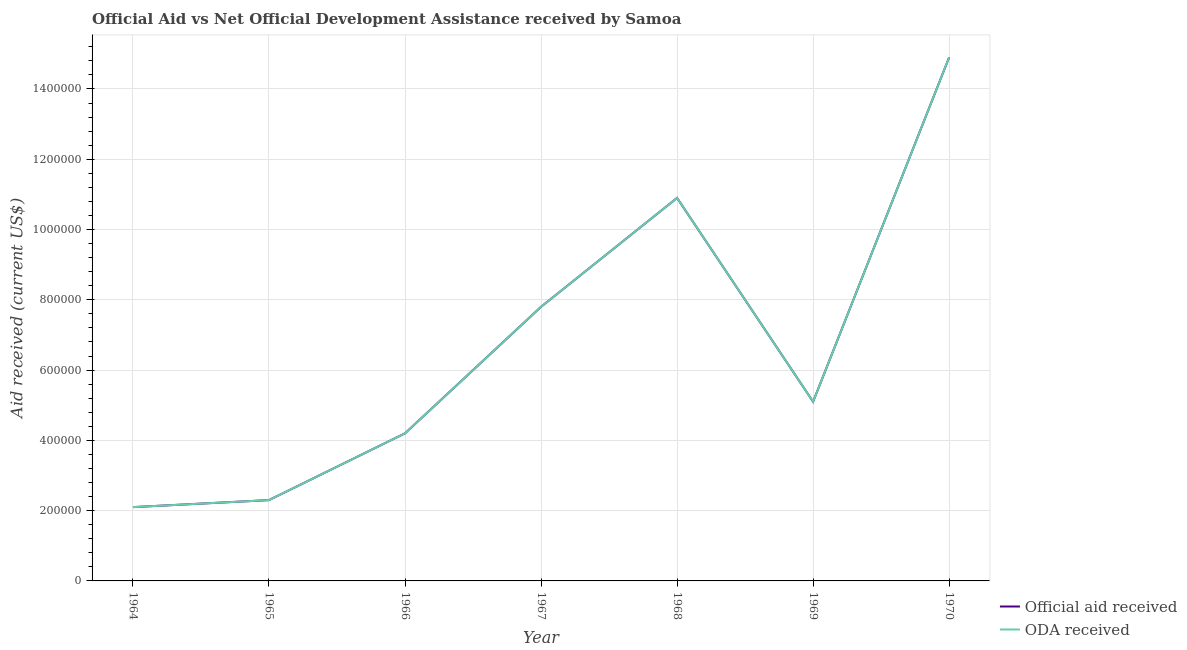Is the number of lines equal to the number of legend labels?
Your response must be concise. Yes. What is the official aid received in 1970?
Provide a short and direct response. 1.49e+06. Across all years, what is the maximum oda received?
Provide a succinct answer. 1.49e+06. Across all years, what is the minimum official aid received?
Ensure brevity in your answer.  2.10e+05. In which year was the official aid received maximum?
Offer a terse response. 1970. In which year was the official aid received minimum?
Provide a succinct answer. 1964. What is the total official aid received in the graph?
Keep it short and to the point. 4.73e+06. What is the difference between the official aid received in 1964 and that in 1970?
Give a very brief answer. -1.28e+06. What is the difference between the official aid received in 1967 and the oda received in 1965?
Ensure brevity in your answer.  5.50e+05. What is the average oda received per year?
Your response must be concise. 6.76e+05. In the year 1966, what is the difference between the official aid received and oda received?
Ensure brevity in your answer.  0. In how many years, is the official aid received greater than 640000 US$?
Offer a very short reply. 3. What is the ratio of the official aid received in 1966 to that in 1969?
Offer a very short reply. 0.82. Is the difference between the oda received in 1966 and 1968 greater than the difference between the official aid received in 1966 and 1968?
Your answer should be compact. No. What is the difference between the highest and the second highest official aid received?
Provide a succinct answer. 4.00e+05. What is the difference between the highest and the lowest oda received?
Your response must be concise. 1.28e+06. Is the sum of the official aid received in 1965 and 1970 greater than the maximum oda received across all years?
Ensure brevity in your answer.  Yes. Is the official aid received strictly greater than the oda received over the years?
Offer a very short reply. No. What is the difference between two consecutive major ticks on the Y-axis?
Your response must be concise. 2.00e+05. Are the values on the major ticks of Y-axis written in scientific E-notation?
Keep it short and to the point. No. Does the graph contain any zero values?
Provide a succinct answer. No. Does the graph contain grids?
Offer a terse response. Yes. How many legend labels are there?
Keep it short and to the point. 2. What is the title of the graph?
Provide a short and direct response. Official Aid vs Net Official Development Assistance received by Samoa . What is the label or title of the X-axis?
Make the answer very short. Year. What is the label or title of the Y-axis?
Make the answer very short. Aid received (current US$). What is the Aid received (current US$) in Official aid received in 1964?
Keep it short and to the point. 2.10e+05. What is the Aid received (current US$) in Official aid received in 1967?
Give a very brief answer. 7.80e+05. What is the Aid received (current US$) in ODA received in 1967?
Provide a succinct answer. 7.80e+05. What is the Aid received (current US$) in Official aid received in 1968?
Offer a very short reply. 1.09e+06. What is the Aid received (current US$) in ODA received in 1968?
Make the answer very short. 1.09e+06. What is the Aid received (current US$) in Official aid received in 1969?
Provide a succinct answer. 5.10e+05. What is the Aid received (current US$) in ODA received in 1969?
Your answer should be compact. 5.10e+05. What is the Aid received (current US$) of Official aid received in 1970?
Ensure brevity in your answer.  1.49e+06. What is the Aid received (current US$) of ODA received in 1970?
Ensure brevity in your answer.  1.49e+06. Across all years, what is the maximum Aid received (current US$) in Official aid received?
Make the answer very short. 1.49e+06. Across all years, what is the maximum Aid received (current US$) in ODA received?
Your answer should be compact. 1.49e+06. What is the total Aid received (current US$) in Official aid received in the graph?
Provide a succinct answer. 4.73e+06. What is the total Aid received (current US$) in ODA received in the graph?
Your answer should be very brief. 4.73e+06. What is the difference between the Aid received (current US$) in Official aid received in 1964 and that in 1965?
Your answer should be compact. -2.00e+04. What is the difference between the Aid received (current US$) of ODA received in 1964 and that in 1965?
Make the answer very short. -2.00e+04. What is the difference between the Aid received (current US$) of Official aid received in 1964 and that in 1967?
Provide a succinct answer. -5.70e+05. What is the difference between the Aid received (current US$) in ODA received in 1964 and that in 1967?
Your answer should be very brief. -5.70e+05. What is the difference between the Aid received (current US$) in Official aid received in 1964 and that in 1968?
Make the answer very short. -8.80e+05. What is the difference between the Aid received (current US$) in ODA received in 1964 and that in 1968?
Offer a terse response. -8.80e+05. What is the difference between the Aid received (current US$) of Official aid received in 1964 and that in 1970?
Provide a succinct answer. -1.28e+06. What is the difference between the Aid received (current US$) in ODA received in 1964 and that in 1970?
Ensure brevity in your answer.  -1.28e+06. What is the difference between the Aid received (current US$) in Official aid received in 1965 and that in 1966?
Your answer should be compact. -1.90e+05. What is the difference between the Aid received (current US$) in Official aid received in 1965 and that in 1967?
Provide a succinct answer. -5.50e+05. What is the difference between the Aid received (current US$) in ODA received in 1965 and that in 1967?
Your answer should be compact. -5.50e+05. What is the difference between the Aid received (current US$) of Official aid received in 1965 and that in 1968?
Offer a very short reply. -8.60e+05. What is the difference between the Aid received (current US$) in ODA received in 1965 and that in 1968?
Offer a terse response. -8.60e+05. What is the difference between the Aid received (current US$) of Official aid received in 1965 and that in 1969?
Your response must be concise. -2.80e+05. What is the difference between the Aid received (current US$) of ODA received in 1965 and that in 1969?
Ensure brevity in your answer.  -2.80e+05. What is the difference between the Aid received (current US$) of Official aid received in 1965 and that in 1970?
Give a very brief answer. -1.26e+06. What is the difference between the Aid received (current US$) of ODA received in 1965 and that in 1970?
Offer a terse response. -1.26e+06. What is the difference between the Aid received (current US$) of Official aid received in 1966 and that in 1967?
Give a very brief answer. -3.60e+05. What is the difference between the Aid received (current US$) of ODA received in 1966 and that in 1967?
Make the answer very short. -3.60e+05. What is the difference between the Aid received (current US$) of Official aid received in 1966 and that in 1968?
Ensure brevity in your answer.  -6.70e+05. What is the difference between the Aid received (current US$) of ODA received in 1966 and that in 1968?
Offer a very short reply. -6.70e+05. What is the difference between the Aid received (current US$) of Official aid received in 1966 and that in 1970?
Provide a short and direct response. -1.07e+06. What is the difference between the Aid received (current US$) in ODA received in 1966 and that in 1970?
Your answer should be very brief. -1.07e+06. What is the difference between the Aid received (current US$) of Official aid received in 1967 and that in 1968?
Give a very brief answer. -3.10e+05. What is the difference between the Aid received (current US$) in ODA received in 1967 and that in 1968?
Ensure brevity in your answer.  -3.10e+05. What is the difference between the Aid received (current US$) in ODA received in 1967 and that in 1969?
Your answer should be compact. 2.70e+05. What is the difference between the Aid received (current US$) in Official aid received in 1967 and that in 1970?
Provide a succinct answer. -7.10e+05. What is the difference between the Aid received (current US$) in ODA received in 1967 and that in 1970?
Keep it short and to the point. -7.10e+05. What is the difference between the Aid received (current US$) of Official aid received in 1968 and that in 1969?
Your response must be concise. 5.80e+05. What is the difference between the Aid received (current US$) of ODA received in 1968 and that in 1969?
Give a very brief answer. 5.80e+05. What is the difference between the Aid received (current US$) of Official aid received in 1968 and that in 1970?
Your answer should be very brief. -4.00e+05. What is the difference between the Aid received (current US$) of ODA received in 1968 and that in 1970?
Give a very brief answer. -4.00e+05. What is the difference between the Aid received (current US$) of Official aid received in 1969 and that in 1970?
Provide a short and direct response. -9.80e+05. What is the difference between the Aid received (current US$) of ODA received in 1969 and that in 1970?
Your answer should be very brief. -9.80e+05. What is the difference between the Aid received (current US$) of Official aid received in 1964 and the Aid received (current US$) of ODA received in 1966?
Provide a short and direct response. -2.10e+05. What is the difference between the Aid received (current US$) of Official aid received in 1964 and the Aid received (current US$) of ODA received in 1967?
Offer a very short reply. -5.70e+05. What is the difference between the Aid received (current US$) of Official aid received in 1964 and the Aid received (current US$) of ODA received in 1968?
Your answer should be very brief. -8.80e+05. What is the difference between the Aid received (current US$) in Official aid received in 1964 and the Aid received (current US$) in ODA received in 1970?
Your answer should be very brief. -1.28e+06. What is the difference between the Aid received (current US$) of Official aid received in 1965 and the Aid received (current US$) of ODA received in 1967?
Your response must be concise. -5.50e+05. What is the difference between the Aid received (current US$) in Official aid received in 1965 and the Aid received (current US$) in ODA received in 1968?
Provide a short and direct response. -8.60e+05. What is the difference between the Aid received (current US$) in Official aid received in 1965 and the Aid received (current US$) in ODA received in 1969?
Provide a short and direct response. -2.80e+05. What is the difference between the Aid received (current US$) of Official aid received in 1965 and the Aid received (current US$) of ODA received in 1970?
Make the answer very short. -1.26e+06. What is the difference between the Aid received (current US$) in Official aid received in 1966 and the Aid received (current US$) in ODA received in 1967?
Provide a short and direct response. -3.60e+05. What is the difference between the Aid received (current US$) of Official aid received in 1966 and the Aid received (current US$) of ODA received in 1968?
Offer a terse response. -6.70e+05. What is the difference between the Aid received (current US$) in Official aid received in 1966 and the Aid received (current US$) in ODA received in 1970?
Offer a terse response. -1.07e+06. What is the difference between the Aid received (current US$) in Official aid received in 1967 and the Aid received (current US$) in ODA received in 1968?
Provide a succinct answer. -3.10e+05. What is the difference between the Aid received (current US$) of Official aid received in 1967 and the Aid received (current US$) of ODA received in 1970?
Your response must be concise. -7.10e+05. What is the difference between the Aid received (current US$) in Official aid received in 1968 and the Aid received (current US$) in ODA received in 1969?
Ensure brevity in your answer.  5.80e+05. What is the difference between the Aid received (current US$) of Official aid received in 1968 and the Aid received (current US$) of ODA received in 1970?
Offer a very short reply. -4.00e+05. What is the difference between the Aid received (current US$) of Official aid received in 1969 and the Aid received (current US$) of ODA received in 1970?
Provide a succinct answer. -9.80e+05. What is the average Aid received (current US$) in Official aid received per year?
Offer a very short reply. 6.76e+05. What is the average Aid received (current US$) of ODA received per year?
Your answer should be very brief. 6.76e+05. In the year 1966, what is the difference between the Aid received (current US$) of Official aid received and Aid received (current US$) of ODA received?
Give a very brief answer. 0. In the year 1968, what is the difference between the Aid received (current US$) of Official aid received and Aid received (current US$) of ODA received?
Make the answer very short. 0. In the year 1969, what is the difference between the Aid received (current US$) in Official aid received and Aid received (current US$) in ODA received?
Ensure brevity in your answer.  0. What is the ratio of the Aid received (current US$) in ODA received in 1964 to that in 1965?
Give a very brief answer. 0.91. What is the ratio of the Aid received (current US$) of ODA received in 1964 to that in 1966?
Offer a very short reply. 0.5. What is the ratio of the Aid received (current US$) of Official aid received in 1964 to that in 1967?
Your answer should be compact. 0.27. What is the ratio of the Aid received (current US$) in ODA received in 1964 to that in 1967?
Keep it short and to the point. 0.27. What is the ratio of the Aid received (current US$) in Official aid received in 1964 to that in 1968?
Your response must be concise. 0.19. What is the ratio of the Aid received (current US$) in ODA received in 1964 to that in 1968?
Ensure brevity in your answer.  0.19. What is the ratio of the Aid received (current US$) of Official aid received in 1964 to that in 1969?
Give a very brief answer. 0.41. What is the ratio of the Aid received (current US$) in ODA received in 1964 to that in 1969?
Ensure brevity in your answer.  0.41. What is the ratio of the Aid received (current US$) in Official aid received in 1964 to that in 1970?
Give a very brief answer. 0.14. What is the ratio of the Aid received (current US$) in ODA received in 1964 to that in 1970?
Offer a terse response. 0.14. What is the ratio of the Aid received (current US$) of Official aid received in 1965 to that in 1966?
Your response must be concise. 0.55. What is the ratio of the Aid received (current US$) in ODA received in 1965 to that in 1966?
Your answer should be very brief. 0.55. What is the ratio of the Aid received (current US$) of Official aid received in 1965 to that in 1967?
Provide a short and direct response. 0.29. What is the ratio of the Aid received (current US$) of ODA received in 1965 to that in 1967?
Your answer should be compact. 0.29. What is the ratio of the Aid received (current US$) of Official aid received in 1965 to that in 1968?
Offer a very short reply. 0.21. What is the ratio of the Aid received (current US$) of ODA received in 1965 to that in 1968?
Provide a succinct answer. 0.21. What is the ratio of the Aid received (current US$) of Official aid received in 1965 to that in 1969?
Offer a terse response. 0.45. What is the ratio of the Aid received (current US$) in ODA received in 1965 to that in 1969?
Ensure brevity in your answer.  0.45. What is the ratio of the Aid received (current US$) in Official aid received in 1965 to that in 1970?
Offer a terse response. 0.15. What is the ratio of the Aid received (current US$) in ODA received in 1965 to that in 1970?
Provide a succinct answer. 0.15. What is the ratio of the Aid received (current US$) of Official aid received in 1966 to that in 1967?
Ensure brevity in your answer.  0.54. What is the ratio of the Aid received (current US$) in ODA received in 1966 to that in 1967?
Offer a very short reply. 0.54. What is the ratio of the Aid received (current US$) in Official aid received in 1966 to that in 1968?
Provide a short and direct response. 0.39. What is the ratio of the Aid received (current US$) in ODA received in 1966 to that in 1968?
Keep it short and to the point. 0.39. What is the ratio of the Aid received (current US$) in Official aid received in 1966 to that in 1969?
Give a very brief answer. 0.82. What is the ratio of the Aid received (current US$) in ODA received in 1966 to that in 1969?
Make the answer very short. 0.82. What is the ratio of the Aid received (current US$) in Official aid received in 1966 to that in 1970?
Keep it short and to the point. 0.28. What is the ratio of the Aid received (current US$) of ODA received in 1966 to that in 1970?
Make the answer very short. 0.28. What is the ratio of the Aid received (current US$) in Official aid received in 1967 to that in 1968?
Provide a succinct answer. 0.72. What is the ratio of the Aid received (current US$) in ODA received in 1967 to that in 1968?
Your answer should be compact. 0.72. What is the ratio of the Aid received (current US$) of Official aid received in 1967 to that in 1969?
Offer a very short reply. 1.53. What is the ratio of the Aid received (current US$) of ODA received in 1967 to that in 1969?
Provide a short and direct response. 1.53. What is the ratio of the Aid received (current US$) in Official aid received in 1967 to that in 1970?
Offer a very short reply. 0.52. What is the ratio of the Aid received (current US$) of ODA received in 1967 to that in 1970?
Offer a terse response. 0.52. What is the ratio of the Aid received (current US$) of Official aid received in 1968 to that in 1969?
Provide a short and direct response. 2.14. What is the ratio of the Aid received (current US$) in ODA received in 1968 to that in 1969?
Give a very brief answer. 2.14. What is the ratio of the Aid received (current US$) of Official aid received in 1968 to that in 1970?
Ensure brevity in your answer.  0.73. What is the ratio of the Aid received (current US$) of ODA received in 1968 to that in 1970?
Offer a very short reply. 0.73. What is the ratio of the Aid received (current US$) of Official aid received in 1969 to that in 1970?
Your answer should be compact. 0.34. What is the ratio of the Aid received (current US$) in ODA received in 1969 to that in 1970?
Provide a short and direct response. 0.34. What is the difference between the highest and the second highest Aid received (current US$) in Official aid received?
Provide a succinct answer. 4.00e+05. What is the difference between the highest and the lowest Aid received (current US$) of Official aid received?
Give a very brief answer. 1.28e+06. What is the difference between the highest and the lowest Aid received (current US$) of ODA received?
Your response must be concise. 1.28e+06. 